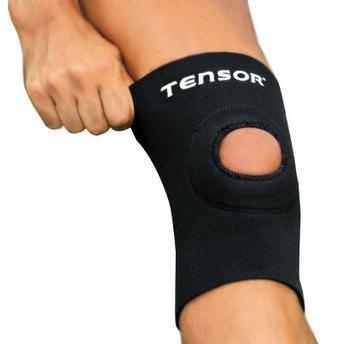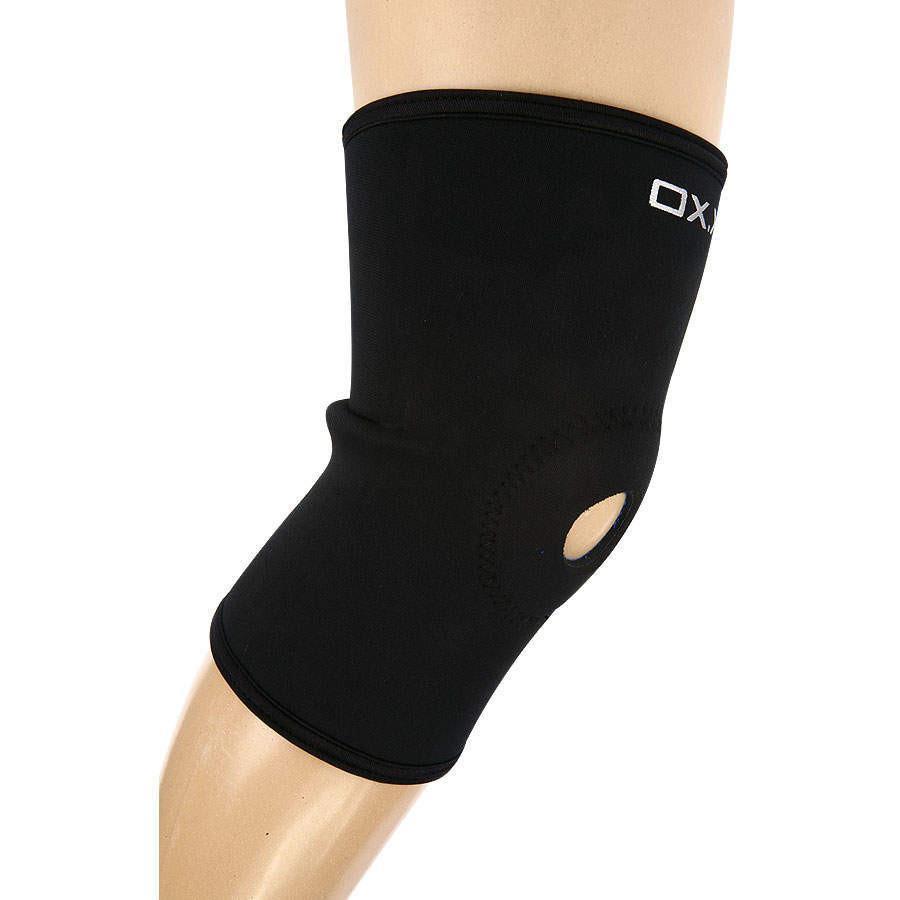The first image is the image on the left, the second image is the image on the right. Examine the images to the left and right. Is the description "In each image, a single black kneepad on a human leg is made with a round hole at the center of the knee." accurate? Answer yes or no. Yes. The first image is the image on the left, the second image is the image on the right. For the images shown, is this caption "Every knee pad has a hole at the kneecap area." true? Answer yes or no. Yes. 